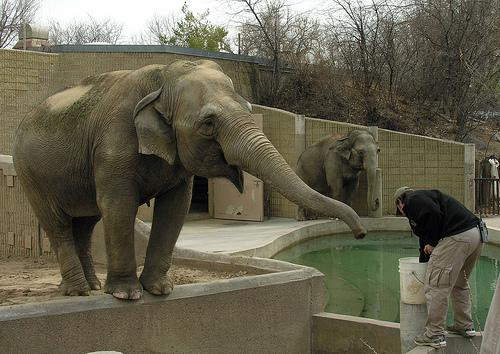Question: how many elephants are there?
Choices:
A. Three.
B. Two.
C. Four.
D. Five.
Answer with the letter. Answer: B Question: why is the elephant trunk out?
Choices:
A. Reaching for something.
B. Bathing.
C. Drinking.
D. Eating.
Answer with the letter. Answer: A Question: who is the man?
Choices:
A. A ringmaster.
B. A lion tamer.
C. A zoo keeper.
D. A hunter.
Answer with the letter. Answer: C 